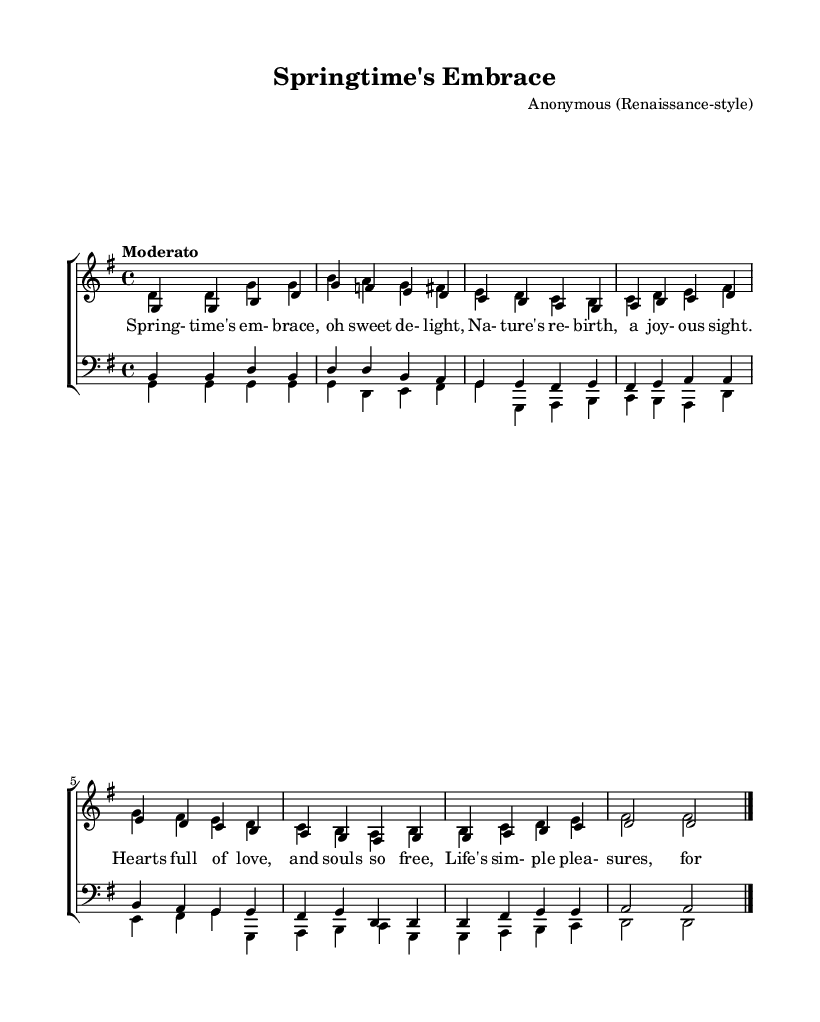What is the key signature of this music? The music is in G major, indicated by the one sharp in the key signature.
Answer: G major What is the time signature? The time signature is indicated at the beginning of the piece. It shows a four on the top and a four on the bottom, meaning it is four beats per measure.
Answer: Four four What is the tempo marking for this piece? The tempo marking is labeled as "Moderato," which typically indicates a moderate pace in music.
Answer: Moderato How many measures are there in the soprano part? By counting the vertical bar lines indicating the end of each measure, there are a total of eight measures in the soprano part.
Answer: Eight Which voice part has the highest pitch range in this composition? The soprano part is typically the highest in vocal compositions, characterized by higher note ranges compared to the other parts such as alto, tenor, or bass.
Answer: Soprano What is the text theme of the lyrics for this madrigal? The lyrics celebrate the themes of nature's beauty and the joys of life, indicative of the Renaissance spirit of embracing human emotions and the beauty around.
Answer: Celebration of life How many different voice parts are present in this piece? There are four distinct voice parts included in the score: soprano, alto, tenor, and bass, often forming a choral texture typical of madrigals.
Answer: Four 